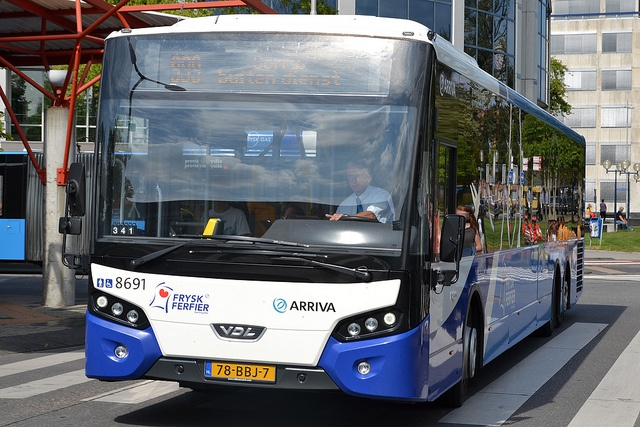Describe the objects in this image and their specific colors. I can see bus in black, white, gray, and darkgray tones, people in black, darkgray, and gray tones, people in black, darkblue, and blue tones, people in black and gray tones, and people in black, maroon, olive, and brown tones in this image. 